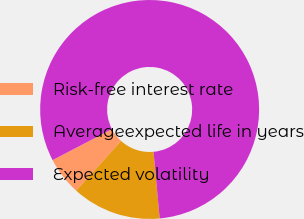Convert chart to OTSL. <chart><loc_0><loc_0><loc_500><loc_500><pie_chart><fcel>Risk-free interest rate<fcel>Averageexpected life in years<fcel>Expected volatility<nl><fcel>5.63%<fcel>13.18%<fcel>81.19%<nl></chart> 